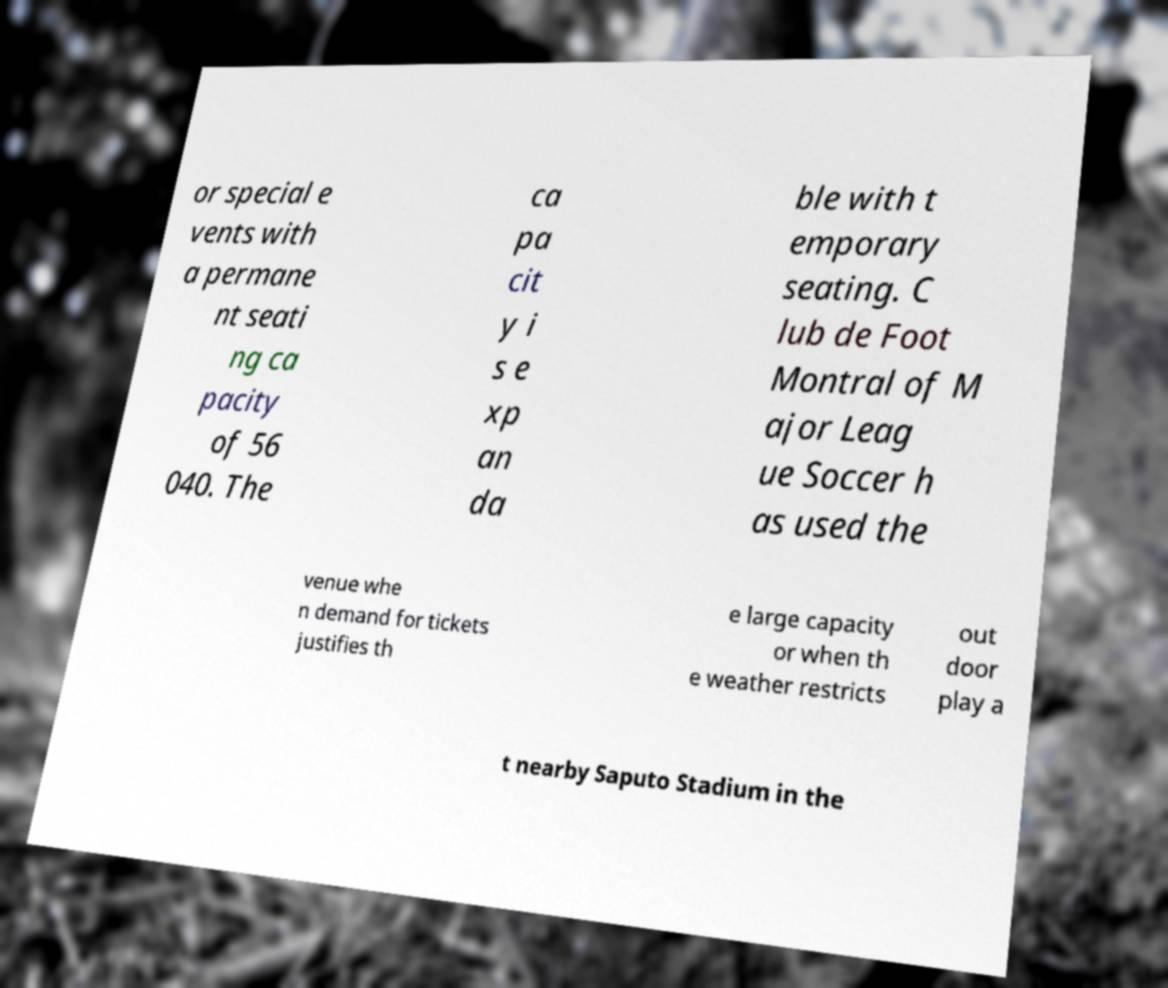I need the written content from this picture converted into text. Can you do that? or special e vents with a permane nt seati ng ca pacity of 56 040. The ca pa cit y i s e xp an da ble with t emporary seating. C lub de Foot Montral of M ajor Leag ue Soccer h as used the venue whe n demand for tickets justifies th e large capacity or when th e weather restricts out door play a t nearby Saputo Stadium in the 